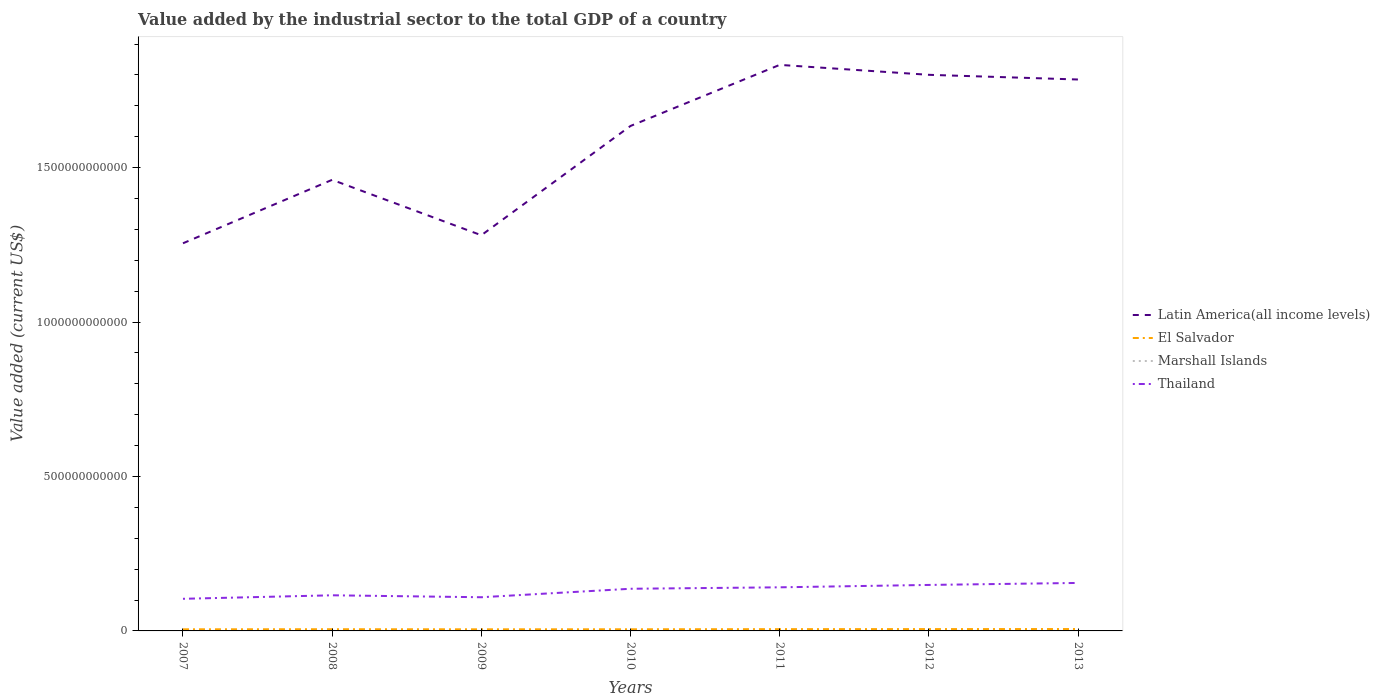Is the number of lines equal to the number of legend labels?
Provide a short and direct response. Yes. Across all years, what is the maximum value added by the industrial sector to the total GDP in Marshall Islands?
Keep it short and to the point. 1.76e+07. What is the total value added by the industrial sector to the total GDP in Thailand in the graph?
Offer a terse response. -3.25e+1. What is the difference between the highest and the second highest value added by the industrial sector to the total GDP in El Salvador?
Your answer should be compact. 8.95e+08. What is the difference between the highest and the lowest value added by the industrial sector to the total GDP in Thailand?
Your response must be concise. 4. How many lines are there?
Make the answer very short. 4. What is the difference between two consecutive major ticks on the Y-axis?
Keep it short and to the point. 5.00e+11. Does the graph contain any zero values?
Make the answer very short. No. Does the graph contain grids?
Your answer should be very brief. No. Where does the legend appear in the graph?
Offer a terse response. Center right. How are the legend labels stacked?
Keep it short and to the point. Vertical. What is the title of the graph?
Ensure brevity in your answer.  Value added by the industrial sector to the total GDP of a country. What is the label or title of the Y-axis?
Give a very brief answer. Value added (current US$). What is the Value added (current US$) in Latin America(all income levels) in 2007?
Provide a short and direct response. 1.26e+12. What is the Value added (current US$) in El Salvador in 2007?
Give a very brief answer. 5.23e+09. What is the Value added (current US$) of Marshall Islands in 2007?
Ensure brevity in your answer.  1.90e+07. What is the Value added (current US$) of Thailand in 2007?
Provide a short and direct response. 1.04e+11. What is the Value added (current US$) in Latin America(all income levels) in 2008?
Give a very brief answer. 1.46e+12. What is the Value added (current US$) of El Salvador in 2008?
Give a very brief answer. 5.49e+09. What is the Value added (current US$) of Marshall Islands in 2008?
Your response must be concise. 1.95e+07. What is the Value added (current US$) of Thailand in 2008?
Ensure brevity in your answer.  1.15e+11. What is the Value added (current US$) in Latin America(all income levels) in 2009?
Give a very brief answer. 1.28e+12. What is the Value added (current US$) in El Salvador in 2009?
Give a very brief answer. 5.21e+09. What is the Value added (current US$) in Marshall Islands in 2009?
Keep it short and to the point. 1.76e+07. What is the Value added (current US$) in Thailand in 2009?
Your answer should be compact. 1.09e+11. What is the Value added (current US$) in Latin America(all income levels) in 2010?
Provide a succinct answer. 1.63e+12. What is the Value added (current US$) in El Salvador in 2010?
Your response must be concise. 5.31e+09. What is the Value added (current US$) in Marshall Islands in 2010?
Offer a very short reply. 1.83e+07. What is the Value added (current US$) in Thailand in 2010?
Ensure brevity in your answer.  1.36e+11. What is the Value added (current US$) of Latin America(all income levels) in 2011?
Offer a very short reply. 1.83e+12. What is the Value added (current US$) of El Salvador in 2011?
Keep it short and to the point. 5.74e+09. What is the Value added (current US$) in Marshall Islands in 2011?
Provide a short and direct response. 2.13e+07. What is the Value added (current US$) in Thailand in 2011?
Your response must be concise. 1.41e+11. What is the Value added (current US$) in Latin America(all income levels) in 2012?
Make the answer very short. 1.80e+12. What is the Value added (current US$) in El Salvador in 2012?
Provide a succinct answer. 5.91e+09. What is the Value added (current US$) of Marshall Islands in 2012?
Make the answer very short. 1.97e+07. What is the Value added (current US$) of Thailand in 2012?
Your response must be concise. 1.49e+11. What is the Value added (current US$) of Latin America(all income levels) in 2013?
Give a very brief answer. 1.79e+12. What is the Value added (current US$) in El Salvador in 2013?
Provide a short and direct response. 6.10e+09. What is the Value added (current US$) of Marshall Islands in 2013?
Give a very brief answer. 1.86e+07. What is the Value added (current US$) of Thailand in 2013?
Your response must be concise. 1.55e+11. Across all years, what is the maximum Value added (current US$) of Latin America(all income levels)?
Ensure brevity in your answer.  1.83e+12. Across all years, what is the maximum Value added (current US$) of El Salvador?
Provide a succinct answer. 6.10e+09. Across all years, what is the maximum Value added (current US$) in Marshall Islands?
Make the answer very short. 2.13e+07. Across all years, what is the maximum Value added (current US$) in Thailand?
Keep it short and to the point. 1.55e+11. Across all years, what is the minimum Value added (current US$) of Latin America(all income levels)?
Your answer should be compact. 1.26e+12. Across all years, what is the minimum Value added (current US$) of El Salvador?
Ensure brevity in your answer.  5.21e+09. Across all years, what is the minimum Value added (current US$) in Marshall Islands?
Make the answer very short. 1.76e+07. Across all years, what is the minimum Value added (current US$) in Thailand?
Your answer should be very brief. 1.04e+11. What is the total Value added (current US$) of Latin America(all income levels) in the graph?
Ensure brevity in your answer.  1.10e+13. What is the total Value added (current US$) in El Salvador in the graph?
Provide a succinct answer. 3.90e+1. What is the total Value added (current US$) in Marshall Islands in the graph?
Provide a succinct answer. 1.34e+08. What is the total Value added (current US$) in Thailand in the graph?
Offer a terse response. 9.10e+11. What is the difference between the Value added (current US$) in Latin America(all income levels) in 2007 and that in 2008?
Make the answer very short. -2.05e+11. What is the difference between the Value added (current US$) in El Salvador in 2007 and that in 2008?
Ensure brevity in your answer.  -2.62e+08. What is the difference between the Value added (current US$) in Marshall Islands in 2007 and that in 2008?
Provide a short and direct response. -4.33e+05. What is the difference between the Value added (current US$) in Thailand in 2007 and that in 2008?
Ensure brevity in your answer.  -1.14e+1. What is the difference between the Value added (current US$) of Latin America(all income levels) in 2007 and that in 2009?
Your answer should be very brief. -2.60e+1. What is the difference between the Value added (current US$) of El Salvador in 2007 and that in 2009?
Your response must be concise. 2.62e+07. What is the difference between the Value added (current US$) in Marshall Islands in 2007 and that in 2009?
Your response must be concise. 1.47e+06. What is the difference between the Value added (current US$) of Thailand in 2007 and that in 2009?
Your answer should be very brief. -5.06e+09. What is the difference between the Value added (current US$) in Latin America(all income levels) in 2007 and that in 2010?
Your answer should be very brief. -3.80e+11. What is the difference between the Value added (current US$) in El Salvador in 2007 and that in 2010?
Offer a very short reply. -7.81e+07. What is the difference between the Value added (current US$) of Marshall Islands in 2007 and that in 2010?
Your answer should be compact. 7.64e+05. What is the difference between the Value added (current US$) of Thailand in 2007 and that in 2010?
Your answer should be compact. -3.25e+1. What is the difference between the Value added (current US$) in Latin America(all income levels) in 2007 and that in 2011?
Keep it short and to the point. -5.78e+11. What is the difference between the Value added (current US$) in El Salvador in 2007 and that in 2011?
Provide a succinct answer. -5.03e+08. What is the difference between the Value added (current US$) of Marshall Islands in 2007 and that in 2011?
Provide a succinct answer. -2.33e+06. What is the difference between the Value added (current US$) in Thailand in 2007 and that in 2011?
Your answer should be very brief. -3.72e+1. What is the difference between the Value added (current US$) in Latin America(all income levels) in 2007 and that in 2012?
Your response must be concise. -5.45e+11. What is the difference between the Value added (current US$) in El Salvador in 2007 and that in 2012?
Offer a terse response. -6.78e+08. What is the difference between the Value added (current US$) in Marshall Islands in 2007 and that in 2012?
Make the answer very short. -6.45e+05. What is the difference between the Value added (current US$) of Thailand in 2007 and that in 2012?
Your response must be concise. -4.49e+1. What is the difference between the Value added (current US$) of Latin America(all income levels) in 2007 and that in 2013?
Offer a very short reply. -5.30e+11. What is the difference between the Value added (current US$) of El Salvador in 2007 and that in 2013?
Provide a succinct answer. -8.69e+08. What is the difference between the Value added (current US$) of Marshall Islands in 2007 and that in 2013?
Keep it short and to the point. 3.76e+05. What is the difference between the Value added (current US$) in Thailand in 2007 and that in 2013?
Make the answer very short. -5.14e+1. What is the difference between the Value added (current US$) in Latin America(all income levels) in 2008 and that in 2009?
Your answer should be very brief. 1.79e+11. What is the difference between the Value added (current US$) of El Salvador in 2008 and that in 2009?
Your answer should be compact. 2.88e+08. What is the difference between the Value added (current US$) of Marshall Islands in 2008 and that in 2009?
Provide a succinct answer. 1.90e+06. What is the difference between the Value added (current US$) in Thailand in 2008 and that in 2009?
Your answer should be very brief. 6.30e+09. What is the difference between the Value added (current US$) in Latin America(all income levels) in 2008 and that in 2010?
Make the answer very short. -1.74e+11. What is the difference between the Value added (current US$) in El Salvador in 2008 and that in 2010?
Offer a terse response. 1.84e+08. What is the difference between the Value added (current US$) of Marshall Islands in 2008 and that in 2010?
Your answer should be very brief. 1.20e+06. What is the difference between the Value added (current US$) in Thailand in 2008 and that in 2010?
Make the answer very short. -2.11e+1. What is the difference between the Value added (current US$) of Latin America(all income levels) in 2008 and that in 2011?
Provide a short and direct response. -3.72e+11. What is the difference between the Value added (current US$) in El Salvador in 2008 and that in 2011?
Keep it short and to the point. -2.41e+08. What is the difference between the Value added (current US$) of Marshall Islands in 2008 and that in 2011?
Make the answer very short. -1.89e+06. What is the difference between the Value added (current US$) of Thailand in 2008 and that in 2011?
Provide a succinct answer. -2.58e+1. What is the difference between the Value added (current US$) of Latin America(all income levels) in 2008 and that in 2012?
Your answer should be compact. -3.40e+11. What is the difference between the Value added (current US$) of El Salvador in 2008 and that in 2012?
Your response must be concise. -4.16e+08. What is the difference between the Value added (current US$) in Marshall Islands in 2008 and that in 2012?
Your response must be concise. -2.12e+05. What is the difference between the Value added (current US$) of Thailand in 2008 and that in 2012?
Your response must be concise. -3.35e+1. What is the difference between the Value added (current US$) in Latin America(all income levels) in 2008 and that in 2013?
Your response must be concise. -3.25e+11. What is the difference between the Value added (current US$) of El Salvador in 2008 and that in 2013?
Keep it short and to the point. -6.07e+08. What is the difference between the Value added (current US$) of Marshall Islands in 2008 and that in 2013?
Offer a terse response. 8.09e+05. What is the difference between the Value added (current US$) of Thailand in 2008 and that in 2013?
Give a very brief answer. -4.00e+1. What is the difference between the Value added (current US$) in Latin America(all income levels) in 2009 and that in 2010?
Your answer should be very brief. -3.54e+11. What is the difference between the Value added (current US$) in El Salvador in 2009 and that in 2010?
Your response must be concise. -1.04e+08. What is the difference between the Value added (current US$) of Marshall Islands in 2009 and that in 2010?
Your answer should be compact. -7.02e+05. What is the difference between the Value added (current US$) in Thailand in 2009 and that in 2010?
Ensure brevity in your answer.  -2.74e+1. What is the difference between the Value added (current US$) in Latin America(all income levels) in 2009 and that in 2011?
Make the answer very short. -5.52e+11. What is the difference between the Value added (current US$) in El Salvador in 2009 and that in 2011?
Provide a short and direct response. -5.29e+08. What is the difference between the Value added (current US$) of Marshall Islands in 2009 and that in 2011?
Offer a terse response. -3.79e+06. What is the difference between the Value added (current US$) in Thailand in 2009 and that in 2011?
Offer a very short reply. -3.21e+1. What is the difference between the Value added (current US$) in Latin America(all income levels) in 2009 and that in 2012?
Make the answer very short. -5.19e+11. What is the difference between the Value added (current US$) in El Salvador in 2009 and that in 2012?
Offer a very short reply. -7.04e+08. What is the difference between the Value added (current US$) in Marshall Islands in 2009 and that in 2012?
Give a very brief answer. -2.11e+06. What is the difference between the Value added (current US$) of Thailand in 2009 and that in 2012?
Make the answer very short. -3.99e+1. What is the difference between the Value added (current US$) of Latin America(all income levels) in 2009 and that in 2013?
Provide a short and direct response. -5.04e+11. What is the difference between the Value added (current US$) of El Salvador in 2009 and that in 2013?
Offer a very short reply. -8.95e+08. What is the difference between the Value added (current US$) of Marshall Islands in 2009 and that in 2013?
Provide a succinct answer. -1.09e+06. What is the difference between the Value added (current US$) of Thailand in 2009 and that in 2013?
Ensure brevity in your answer.  -4.63e+1. What is the difference between the Value added (current US$) in Latin America(all income levels) in 2010 and that in 2011?
Your response must be concise. -1.98e+11. What is the difference between the Value added (current US$) in El Salvador in 2010 and that in 2011?
Keep it short and to the point. -4.25e+08. What is the difference between the Value added (current US$) of Marshall Islands in 2010 and that in 2011?
Your answer should be very brief. -3.09e+06. What is the difference between the Value added (current US$) of Thailand in 2010 and that in 2011?
Give a very brief answer. -4.69e+09. What is the difference between the Value added (current US$) of Latin America(all income levels) in 2010 and that in 2012?
Provide a short and direct response. -1.66e+11. What is the difference between the Value added (current US$) in El Salvador in 2010 and that in 2012?
Give a very brief answer. -6.00e+08. What is the difference between the Value added (current US$) of Marshall Islands in 2010 and that in 2012?
Your response must be concise. -1.41e+06. What is the difference between the Value added (current US$) in Thailand in 2010 and that in 2012?
Your answer should be compact. -1.24e+1. What is the difference between the Value added (current US$) in Latin America(all income levels) in 2010 and that in 2013?
Offer a very short reply. -1.50e+11. What is the difference between the Value added (current US$) of El Salvador in 2010 and that in 2013?
Keep it short and to the point. -7.91e+08. What is the difference between the Value added (current US$) of Marshall Islands in 2010 and that in 2013?
Ensure brevity in your answer.  -3.88e+05. What is the difference between the Value added (current US$) in Thailand in 2010 and that in 2013?
Make the answer very short. -1.89e+1. What is the difference between the Value added (current US$) in Latin America(all income levels) in 2011 and that in 2012?
Your answer should be very brief. 3.22e+1. What is the difference between the Value added (current US$) in El Salvador in 2011 and that in 2012?
Offer a terse response. -1.75e+08. What is the difference between the Value added (current US$) in Marshall Islands in 2011 and that in 2012?
Offer a terse response. 1.68e+06. What is the difference between the Value added (current US$) in Thailand in 2011 and that in 2012?
Your answer should be compact. -7.72e+09. What is the difference between the Value added (current US$) of Latin America(all income levels) in 2011 and that in 2013?
Keep it short and to the point. 4.73e+1. What is the difference between the Value added (current US$) in El Salvador in 2011 and that in 2013?
Give a very brief answer. -3.66e+08. What is the difference between the Value added (current US$) of Marshall Islands in 2011 and that in 2013?
Provide a succinct answer. 2.70e+06. What is the difference between the Value added (current US$) in Thailand in 2011 and that in 2013?
Give a very brief answer. -1.42e+1. What is the difference between the Value added (current US$) of Latin America(all income levels) in 2012 and that in 2013?
Offer a terse response. 1.52e+1. What is the difference between the Value added (current US$) of El Salvador in 2012 and that in 2013?
Provide a short and direct response. -1.91e+08. What is the difference between the Value added (current US$) of Marshall Islands in 2012 and that in 2013?
Your answer should be very brief. 1.02e+06. What is the difference between the Value added (current US$) in Thailand in 2012 and that in 2013?
Ensure brevity in your answer.  -6.46e+09. What is the difference between the Value added (current US$) in Latin America(all income levels) in 2007 and the Value added (current US$) in El Salvador in 2008?
Your answer should be very brief. 1.25e+12. What is the difference between the Value added (current US$) in Latin America(all income levels) in 2007 and the Value added (current US$) in Marshall Islands in 2008?
Offer a terse response. 1.25e+12. What is the difference between the Value added (current US$) of Latin America(all income levels) in 2007 and the Value added (current US$) of Thailand in 2008?
Your answer should be compact. 1.14e+12. What is the difference between the Value added (current US$) of El Salvador in 2007 and the Value added (current US$) of Marshall Islands in 2008?
Offer a very short reply. 5.21e+09. What is the difference between the Value added (current US$) in El Salvador in 2007 and the Value added (current US$) in Thailand in 2008?
Your answer should be compact. -1.10e+11. What is the difference between the Value added (current US$) of Marshall Islands in 2007 and the Value added (current US$) of Thailand in 2008?
Ensure brevity in your answer.  -1.15e+11. What is the difference between the Value added (current US$) of Latin America(all income levels) in 2007 and the Value added (current US$) of El Salvador in 2009?
Make the answer very short. 1.25e+12. What is the difference between the Value added (current US$) in Latin America(all income levels) in 2007 and the Value added (current US$) in Marshall Islands in 2009?
Offer a terse response. 1.25e+12. What is the difference between the Value added (current US$) of Latin America(all income levels) in 2007 and the Value added (current US$) of Thailand in 2009?
Offer a very short reply. 1.15e+12. What is the difference between the Value added (current US$) of El Salvador in 2007 and the Value added (current US$) of Marshall Islands in 2009?
Your response must be concise. 5.21e+09. What is the difference between the Value added (current US$) of El Salvador in 2007 and the Value added (current US$) of Thailand in 2009?
Provide a short and direct response. -1.04e+11. What is the difference between the Value added (current US$) of Marshall Islands in 2007 and the Value added (current US$) of Thailand in 2009?
Your answer should be very brief. -1.09e+11. What is the difference between the Value added (current US$) in Latin America(all income levels) in 2007 and the Value added (current US$) in El Salvador in 2010?
Give a very brief answer. 1.25e+12. What is the difference between the Value added (current US$) in Latin America(all income levels) in 2007 and the Value added (current US$) in Marshall Islands in 2010?
Offer a very short reply. 1.25e+12. What is the difference between the Value added (current US$) in Latin America(all income levels) in 2007 and the Value added (current US$) in Thailand in 2010?
Ensure brevity in your answer.  1.12e+12. What is the difference between the Value added (current US$) in El Salvador in 2007 and the Value added (current US$) in Marshall Islands in 2010?
Your answer should be compact. 5.21e+09. What is the difference between the Value added (current US$) of El Salvador in 2007 and the Value added (current US$) of Thailand in 2010?
Make the answer very short. -1.31e+11. What is the difference between the Value added (current US$) of Marshall Islands in 2007 and the Value added (current US$) of Thailand in 2010?
Your answer should be very brief. -1.36e+11. What is the difference between the Value added (current US$) in Latin America(all income levels) in 2007 and the Value added (current US$) in El Salvador in 2011?
Give a very brief answer. 1.25e+12. What is the difference between the Value added (current US$) of Latin America(all income levels) in 2007 and the Value added (current US$) of Marshall Islands in 2011?
Offer a very short reply. 1.25e+12. What is the difference between the Value added (current US$) of Latin America(all income levels) in 2007 and the Value added (current US$) of Thailand in 2011?
Your response must be concise. 1.11e+12. What is the difference between the Value added (current US$) in El Salvador in 2007 and the Value added (current US$) in Marshall Islands in 2011?
Give a very brief answer. 5.21e+09. What is the difference between the Value added (current US$) in El Salvador in 2007 and the Value added (current US$) in Thailand in 2011?
Offer a terse response. -1.36e+11. What is the difference between the Value added (current US$) of Marshall Islands in 2007 and the Value added (current US$) of Thailand in 2011?
Provide a succinct answer. -1.41e+11. What is the difference between the Value added (current US$) in Latin America(all income levels) in 2007 and the Value added (current US$) in El Salvador in 2012?
Provide a short and direct response. 1.25e+12. What is the difference between the Value added (current US$) in Latin America(all income levels) in 2007 and the Value added (current US$) in Marshall Islands in 2012?
Offer a terse response. 1.25e+12. What is the difference between the Value added (current US$) in Latin America(all income levels) in 2007 and the Value added (current US$) in Thailand in 2012?
Make the answer very short. 1.11e+12. What is the difference between the Value added (current US$) in El Salvador in 2007 and the Value added (current US$) in Marshall Islands in 2012?
Give a very brief answer. 5.21e+09. What is the difference between the Value added (current US$) of El Salvador in 2007 and the Value added (current US$) of Thailand in 2012?
Keep it short and to the point. -1.44e+11. What is the difference between the Value added (current US$) of Marshall Islands in 2007 and the Value added (current US$) of Thailand in 2012?
Ensure brevity in your answer.  -1.49e+11. What is the difference between the Value added (current US$) in Latin America(all income levels) in 2007 and the Value added (current US$) in El Salvador in 2013?
Offer a terse response. 1.25e+12. What is the difference between the Value added (current US$) in Latin America(all income levels) in 2007 and the Value added (current US$) in Marshall Islands in 2013?
Ensure brevity in your answer.  1.25e+12. What is the difference between the Value added (current US$) in Latin America(all income levels) in 2007 and the Value added (current US$) in Thailand in 2013?
Your response must be concise. 1.10e+12. What is the difference between the Value added (current US$) in El Salvador in 2007 and the Value added (current US$) in Marshall Islands in 2013?
Keep it short and to the point. 5.21e+09. What is the difference between the Value added (current US$) of El Salvador in 2007 and the Value added (current US$) of Thailand in 2013?
Keep it short and to the point. -1.50e+11. What is the difference between the Value added (current US$) in Marshall Islands in 2007 and the Value added (current US$) in Thailand in 2013?
Offer a terse response. -1.55e+11. What is the difference between the Value added (current US$) of Latin America(all income levels) in 2008 and the Value added (current US$) of El Salvador in 2009?
Offer a very short reply. 1.46e+12. What is the difference between the Value added (current US$) of Latin America(all income levels) in 2008 and the Value added (current US$) of Marshall Islands in 2009?
Offer a terse response. 1.46e+12. What is the difference between the Value added (current US$) of Latin America(all income levels) in 2008 and the Value added (current US$) of Thailand in 2009?
Give a very brief answer. 1.35e+12. What is the difference between the Value added (current US$) of El Salvador in 2008 and the Value added (current US$) of Marshall Islands in 2009?
Give a very brief answer. 5.48e+09. What is the difference between the Value added (current US$) of El Salvador in 2008 and the Value added (current US$) of Thailand in 2009?
Provide a succinct answer. -1.04e+11. What is the difference between the Value added (current US$) in Marshall Islands in 2008 and the Value added (current US$) in Thailand in 2009?
Your answer should be compact. -1.09e+11. What is the difference between the Value added (current US$) in Latin America(all income levels) in 2008 and the Value added (current US$) in El Salvador in 2010?
Make the answer very short. 1.46e+12. What is the difference between the Value added (current US$) in Latin America(all income levels) in 2008 and the Value added (current US$) in Marshall Islands in 2010?
Ensure brevity in your answer.  1.46e+12. What is the difference between the Value added (current US$) of Latin America(all income levels) in 2008 and the Value added (current US$) of Thailand in 2010?
Provide a short and direct response. 1.32e+12. What is the difference between the Value added (current US$) of El Salvador in 2008 and the Value added (current US$) of Marshall Islands in 2010?
Your answer should be very brief. 5.48e+09. What is the difference between the Value added (current US$) in El Salvador in 2008 and the Value added (current US$) in Thailand in 2010?
Keep it short and to the point. -1.31e+11. What is the difference between the Value added (current US$) in Marshall Islands in 2008 and the Value added (current US$) in Thailand in 2010?
Your answer should be very brief. -1.36e+11. What is the difference between the Value added (current US$) of Latin America(all income levels) in 2008 and the Value added (current US$) of El Salvador in 2011?
Give a very brief answer. 1.45e+12. What is the difference between the Value added (current US$) of Latin America(all income levels) in 2008 and the Value added (current US$) of Marshall Islands in 2011?
Make the answer very short. 1.46e+12. What is the difference between the Value added (current US$) in Latin America(all income levels) in 2008 and the Value added (current US$) in Thailand in 2011?
Your response must be concise. 1.32e+12. What is the difference between the Value added (current US$) in El Salvador in 2008 and the Value added (current US$) in Marshall Islands in 2011?
Ensure brevity in your answer.  5.47e+09. What is the difference between the Value added (current US$) of El Salvador in 2008 and the Value added (current US$) of Thailand in 2011?
Make the answer very short. -1.36e+11. What is the difference between the Value added (current US$) in Marshall Islands in 2008 and the Value added (current US$) in Thailand in 2011?
Offer a very short reply. -1.41e+11. What is the difference between the Value added (current US$) of Latin America(all income levels) in 2008 and the Value added (current US$) of El Salvador in 2012?
Your answer should be very brief. 1.45e+12. What is the difference between the Value added (current US$) of Latin America(all income levels) in 2008 and the Value added (current US$) of Marshall Islands in 2012?
Your answer should be compact. 1.46e+12. What is the difference between the Value added (current US$) of Latin America(all income levels) in 2008 and the Value added (current US$) of Thailand in 2012?
Offer a terse response. 1.31e+12. What is the difference between the Value added (current US$) in El Salvador in 2008 and the Value added (current US$) in Marshall Islands in 2012?
Provide a succinct answer. 5.47e+09. What is the difference between the Value added (current US$) of El Salvador in 2008 and the Value added (current US$) of Thailand in 2012?
Your response must be concise. -1.43e+11. What is the difference between the Value added (current US$) of Marshall Islands in 2008 and the Value added (current US$) of Thailand in 2012?
Ensure brevity in your answer.  -1.49e+11. What is the difference between the Value added (current US$) of Latin America(all income levels) in 2008 and the Value added (current US$) of El Salvador in 2013?
Make the answer very short. 1.45e+12. What is the difference between the Value added (current US$) in Latin America(all income levels) in 2008 and the Value added (current US$) in Marshall Islands in 2013?
Your answer should be compact. 1.46e+12. What is the difference between the Value added (current US$) of Latin America(all income levels) in 2008 and the Value added (current US$) of Thailand in 2013?
Your answer should be very brief. 1.31e+12. What is the difference between the Value added (current US$) in El Salvador in 2008 and the Value added (current US$) in Marshall Islands in 2013?
Your answer should be very brief. 5.48e+09. What is the difference between the Value added (current US$) of El Salvador in 2008 and the Value added (current US$) of Thailand in 2013?
Your response must be concise. -1.50e+11. What is the difference between the Value added (current US$) in Marshall Islands in 2008 and the Value added (current US$) in Thailand in 2013?
Ensure brevity in your answer.  -1.55e+11. What is the difference between the Value added (current US$) of Latin America(all income levels) in 2009 and the Value added (current US$) of El Salvador in 2010?
Keep it short and to the point. 1.28e+12. What is the difference between the Value added (current US$) of Latin America(all income levels) in 2009 and the Value added (current US$) of Marshall Islands in 2010?
Provide a succinct answer. 1.28e+12. What is the difference between the Value added (current US$) in Latin America(all income levels) in 2009 and the Value added (current US$) in Thailand in 2010?
Keep it short and to the point. 1.14e+12. What is the difference between the Value added (current US$) of El Salvador in 2009 and the Value added (current US$) of Marshall Islands in 2010?
Keep it short and to the point. 5.19e+09. What is the difference between the Value added (current US$) in El Salvador in 2009 and the Value added (current US$) in Thailand in 2010?
Keep it short and to the point. -1.31e+11. What is the difference between the Value added (current US$) in Marshall Islands in 2009 and the Value added (current US$) in Thailand in 2010?
Keep it short and to the point. -1.36e+11. What is the difference between the Value added (current US$) in Latin America(all income levels) in 2009 and the Value added (current US$) in El Salvador in 2011?
Your answer should be very brief. 1.28e+12. What is the difference between the Value added (current US$) in Latin America(all income levels) in 2009 and the Value added (current US$) in Marshall Islands in 2011?
Offer a terse response. 1.28e+12. What is the difference between the Value added (current US$) of Latin America(all income levels) in 2009 and the Value added (current US$) of Thailand in 2011?
Make the answer very short. 1.14e+12. What is the difference between the Value added (current US$) of El Salvador in 2009 and the Value added (current US$) of Marshall Islands in 2011?
Provide a succinct answer. 5.18e+09. What is the difference between the Value added (current US$) of El Salvador in 2009 and the Value added (current US$) of Thailand in 2011?
Offer a terse response. -1.36e+11. What is the difference between the Value added (current US$) of Marshall Islands in 2009 and the Value added (current US$) of Thailand in 2011?
Your response must be concise. -1.41e+11. What is the difference between the Value added (current US$) of Latin America(all income levels) in 2009 and the Value added (current US$) of El Salvador in 2012?
Provide a succinct answer. 1.28e+12. What is the difference between the Value added (current US$) in Latin America(all income levels) in 2009 and the Value added (current US$) in Marshall Islands in 2012?
Provide a succinct answer. 1.28e+12. What is the difference between the Value added (current US$) in Latin America(all income levels) in 2009 and the Value added (current US$) in Thailand in 2012?
Offer a terse response. 1.13e+12. What is the difference between the Value added (current US$) in El Salvador in 2009 and the Value added (current US$) in Marshall Islands in 2012?
Provide a succinct answer. 5.19e+09. What is the difference between the Value added (current US$) in El Salvador in 2009 and the Value added (current US$) in Thailand in 2012?
Your answer should be compact. -1.44e+11. What is the difference between the Value added (current US$) of Marshall Islands in 2009 and the Value added (current US$) of Thailand in 2012?
Offer a terse response. -1.49e+11. What is the difference between the Value added (current US$) of Latin America(all income levels) in 2009 and the Value added (current US$) of El Salvador in 2013?
Ensure brevity in your answer.  1.27e+12. What is the difference between the Value added (current US$) in Latin America(all income levels) in 2009 and the Value added (current US$) in Marshall Islands in 2013?
Provide a short and direct response. 1.28e+12. What is the difference between the Value added (current US$) of Latin America(all income levels) in 2009 and the Value added (current US$) of Thailand in 2013?
Ensure brevity in your answer.  1.13e+12. What is the difference between the Value added (current US$) in El Salvador in 2009 and the Value added (current US$) in Marshall Islands in 2013?
Give a very brief answer. 5.19e+09. What is the difference between the Value added (current US$) of El Salvador in 2009 and the Value added (current US$) of Thailand in 2013?
Your answer should be compact. -1.50e+11. What is the difference between the Value added (current US$) of Marshall Islands in 2009 and the Value added (current US$) of Thailand in 2013?
Offer a terse response. -1.55e+11. What is the difference between the Value added (current US$) of Latin America(all income levels) in 2010 and the Value added (current US$) of El Salvador in 2011?
Offer a very short reply. 1.63e+12. What is the difference between the Value added (current US$) of Latin America(all income levels) in 2010 and the Value added (current US$) of Marshall Islands in 2011?
Keep it short and to the point. 1.63e+12. What is the difference between the Value added (current US$) in Latin America(all income levels) in 2010 and the Value added (current US$) in Thailand in 2011?
Keep it short and to the point. 1.49e+12. What is the difference between the Value added (current US$) of El Salvador in 2010 and the Value added (current US$) of Marshall Islands in 2011?
Your answer should be compact. 5.29e+09. What is the difference between the Value added (current US$) in El Salvador in 2010 and the Value added (current US$) in Thailand in 2011?
Offer a very short reply. -1.36e+11. What is the difference between the Value added (current US$) of Marshall Islands in 2010 and the Value added (current US$) of Thailand in 2011?
Your response must be concise. -1.41e+11. What is the difference between the Value added (current US$) of Latin America(all income levels) in 2010 and the Value added (current US$) of El Salvador in 2012?
Your response must be concise. 1.63e+12. What is the difference between the Value added (current US$) of Latin America(all income levels) in 2010 and the Value added (current US$) of Marshall Islands in 2012?
Offer a very short reply. 1.63e+12. What is the difference between the Value added (current US$) of Latin America(all income levels) in 2010 and the Value added (current US$) of Thailand in 2012?
Provide a succinct answer. 1.49e+12. What is the difference between the Value added (current US$) of El Salvador in 2010 and the Value added (current US$) of Marshall Islands in 2012?
Your response must be concise. 5.29e+09. What is the difference between the Value added (current US$) of El Salvador in 2010 and the Value added (current US$) of Thailand in 2012?
Make the answer very short. -1.44e+11. What is the difference between the Value added (current US$) of Marshall Islands in 2010 and the Value added (current US$) of Thailand in 2012?
Give a very brief answer. -1.49e+11. What is the difference between the Value added (current US$) of Latin America(all income levels) in 2010 and the Value added (current US$) of El Salvador in 2013?
Provide a succinct answer. 1.63e+12. What is the difference between the Value added (current US$) in Latin America(all income levels) in 2010 and the Value added (current US$) in Marshall Islands in 2013?
Keep it short and to the point. 1.63e+12. What is the difference between the Value added (current US$) of Latin America(all income levels) in 2010 and the Value added (current US$) of Thailand in 2013?
Ensure brevity in your answer.  1.48e+12. What is the difference between the Value added (current US$) of El Salvador in 2010 and the Value added (current US$) of Marshall Islands in 2013?
Provide a short and direct response. 5.29e+09. What is the difference between the Value added (current US$) in El Salvador in 2010 and the Value added (current US$) in Thailand in 2013?
Make the answer very short. -1.50e+11. What is the difference between the Value added (current US$) in Marshall Islands in 2010 and the Value added (current US$) in Thailand in 2013?
Offer a terse response. -1.55e+11. What is the difference between the Value added (current US$) of Latin America(all income levels) in 2011 and the Value added (current US$) of El Salvador in 2012?
Your answer should be very brief. 1.83e+12. What is the difference between the Value added (current US$) of Latin America(all income levels) in 2011 and the Value added (current US$) of Marshall Islands in 2012?
Offer a very short reply. 1.83e+12. What is the difference between the Value added (current US$) of Latin America(all income levels) in 2011 and the Value added (current US$) of Thailand in 2012?
Your answer should be very brief. 1.68e+12. What is the difference between the Value added (current US$) of El Salvador in 2011 and the Value added (current US$) of Marshall Islands in 2012?
Your answer should be very brief. 5.72e+09. What is the difference between the Value added (current US$) in El Salvador in 2011 and the Value added (current US$) in Thailand in 2012?
Offer a very short reply. -1.43e+11. What is the difference between the Value added (current US$) in Marshall Islands in 2011 and the Value added (current US$) in Thailand in 2012?
Give a very brief answer. -1.49e+11. What is the difference between the Value added (current US$) of Latin America(all income levels) in 2011 and the Value added (current US$) of El Salvador in 2013?
Ensure brevity in your answer.  1.83e+12. What is the difference between the Value added (current US$) in Latin America(all income levels) in 2011 and the Value added (current US$) in Marshall Islands in 2013?
Make the answer very short. 1.83e+12. What is the difference between the Value added (current US$) in Latin America(all income levels) in 2011 and the Value added (current US$) in Thailand in 2013?
Keep it short and to the point. 1.68e+12. What is the difference between the Value added (current US$) of El Salvador in 2011 and the Value added (current US$) of Marshall Islands in 2013?
Offer a terse response. 5.72e+09. What is the difference between the Value added (current US$) in El Salvador in 2011 and the Value added (current US$) in Thailand in 2013?
Your answer should be compact. -1.50e+11. What is the difference between the Value added (current US$) in Marshall Islands in 2011 and the Value added (current US$) in Thailand in 2013?
Give a very brief answer. -1.55e+11. What is the difference between the Value added (current US$) in Latin America(all income levels) in 2012 and the Value added (current US$) in El Salvador in 2013?
Provide a succinct answer. 1.79e+12. What is the difference between the Value added (current US$) in Latin America(all income levels) in 2012 and the Value added (current US$) in Marshall Islands in 2013?
Your response must be concise. 1.80e+12. What is the difference between the Value added (current US$) in Latin America(all income levels) in 2012 and the Value added (current US$) in Thailand in 2013?
Provide a short and direct response. 1.65e+12. What is the difference between the Value added (current US$) in El Salvador in 2012 and the Value added (current US$) in Marshall Islands in 2013?
Give a very brief answer. 5.89e+09. What is the difference between the Value added (current US$) of El Salvador in 2012 and the Value added (current US$) of Thailand in 2013?
Offer a terse response. -1.49e+11. What is the difference between the Value added (current US$) of Marshall Islands in 2012 and the Value added (current US$) of Thailand in 2013?
Your answer should be compact. -1.55e+11. What is the average Value added (current US$) in Latin America(all income levels) per year?
Keep it short and to the point. 1.58e+12. What is the average Value added (current US$) in El Salvador per year?
Your answer should be very brief. 5.57e+09. What is the average Value added (current US$) in Marshall Islands per year?
Keep it short and to the point. 1.91e+07. What is the average Value added (current US$) in Thailand per year?
Keep it short and to the point. 1.30e+11. In the year 2007, what is the difference between the Value added (current US$) of Latin America(all income levels) and Value added (current US$) of El Salvador?
Provide a succinct answer. 1.25e+12. In the year 2007, what is the difference between the Value added (current US$) of Latin America(all income levels) and Value added (current US$) of Marshall Islands?
Ensure brevity in your answer.  1.25e+12. In the year 2007, what is the difference between the Value added (current US$) of Latin America(all income levels) and Value added (current US$) of Thailand?
Ensure brevity in your answer.  1.15e+12. In the year 2007, what is the difference between the Value added (current US$) in El Salvador and Value added (current US$) in Marshall Islands?
Ensure brevity in your answer.  5.21e+09. In the year 2007, what is the difference between the Value added (current US$) of El Salvador and Value added (current US$) of Thailand?
Your response must be concise. -9.88e+1. In the year 2007, what is the difference between the Value added (current US$) of Marshall Islands and Value added (current US$) of Thailand?
Your answer should be compact. -1.04e+11. In the year 2008, what is the difference between the Value added (current US$) in Latin America(all income levels) and Value added (current US$) in El Salvador?
Offer a very short reply. 1.45e+12. In the year 2008, what is the difference between the Value added (current US$) of Latin America(all income levels) and Value added (current US$) of Marshall Islands?
Provide a short and direct response. 1.46e+12. In the year 2008, what is the difference between the Value added (current US$) in Latin America(all income levels) and Value added (current US$) in Thailand?
Your answer should be compact. 1.35e+12. In the year 2008, what is the difference between the Value added (current US$) of El Salvador and Value added (current US$) of Marshall Islands?
Keep it short and to the point. 5.47e+09. In the year 2008, what is the difference between the Value added (current US$) in El Salvador and Value added (current US$) in Thailand?
Your answer should be compact. -1.10e+11. In the year 2008, what is the difference between the Value added (current US$) in Marshall Islands and Value added (current US$) in Thailand?
Offer a very short reply. -1.15e+11. In the year 2009, what is the difference between the Value added (current US$) of Latin America(all income levels) and Value added (current US$) of El Salvador?
Provide a succinct answer. 1.28e+12. In the year 2009, what is the difference between the Value added (current US$) of Latin America(all income levels) and Value added (current US$) of Marshall Islands?
Offer a very short reply. 1.28e+12. In the year 2009, what is the difference between the Value added (current US$) of Latin America(all income levels) and Value added (current US$) of Thailand?
Offer a very short reply. 1.17e+12. In the year 2009, what is the difference between the Value added (current US$) of El Salvador and Value added (current US$) of Marshall Islands?
Provide a short and direct response. 5.19e+09. In the year 2009, what is the difference between the Value added (current US$) in El Salvador and Value added (current US$) in Thailand?
Provide a succinct answer. -1.04e+11. In the year 2009, what is the difference between the Value added (current US$) in Marshall Islands and Value added (current US$) in Thailand?
Provide a short and direct response. -1.09e+11. In the year 2010, what is the difference between the Value added (current US$) of Latin America(all income levels) and Value added (current US$) of El Salvador?
Provide a succinct answer. 1.63e+12. In the year 2010, what is the difference between the Value added (current US$) of Latin America(all income levels) and Value added (current US$) of Marshall Islands?
Make the answer very short. 1.63e+12. In the year 2010, what is the difference between the Value added (current US$) of Latin America(all income levels) and Value added (current US$) of Thailand?
Give a very brief answer. 1.50e+12. In the year 2010, what is the difference between the Value added (current US$) of El Salvador and Value added (current US$) of Marshall Islands?
Your answer should be compact. 5.29e+09. In the year 2010, what is the difference between the Value added (current US$) of El Salvador and Value added (current US$) of Thailand?
Offer a terse response. -1.31e+11. In the year 2010, what is the difference between the Value added (current US$) in Marshall Islands and Value added (current US$) in Thailand?
Give a very brief answer. -1.36e+11. In the year 2011, what is the difference between the Value added (current US$) in Latin America(all income levels) and Value added (current US$) in El Salvador?
Make the answer very short. 1.83e+12. In the year 2011, what is the difference between the Value added (current US$) of Latin America(all income levels) and Value added (current US$) of Marshall Islands?
Keep it short and to the point. 1.83e+12. In the year 2011, what is the difference between the Value added (current US$) of Latin America(all income levels) and Value added (current US$) of Thailand?
Keep it short and to the point. 1.69e+12. In the year 2011, what is the difference between the Value added (current US$) of El Salvador and Value added (current US$) of Marshall Islands?
Provide a short and direct response. 5.71e+09. In the year 2011, what is the difference between the Value added (current US$) in El Salvador and Value added (current US$) in Thailand?
Ensure brevity in your answer.  -1.35e+11. In the year 2011, what is the difference between the Value added (current US$) in Marshall Islands and Value added (current US$) in Thailand?
Ensure brevity in your answer.  -1.41e+11. In the year 2012, what is the difference between the Value added (current US$) of Latin America(all income levels) and Value added (current US$) of El Salvador?
Offer a terse response. 1.79e+12. In the year 2012, what is the difference between the Value added (current US$) of Latin America(all income levels) and Value added (current US$) of Marshall Islands?
Your answer should be very brief. 1.80e+12. In the year 2012, what is the difference between the Value added (current US$) in Latin America(all income levels) and Value added (current US$) in Thailand?
Keep it short and to the point. 1.65e+12. In the year 2012, what is the difference between the Value added (current US$) of El Salvador and Value added (current US$) of Marshall Islands?
Give a very brief answer. 5.89e+09. In the year 2012, what is the difference between the Value added (current US$) of El Salvador and Value added (current US$) of Thailand?
Provide a short and direct response. -1.43e+11. In the year 2012, what is the difference between the Value added (current US$) of Marshall Islands and Value added (current US$) of Thailand?
Offer a very short reply. -1.49e+11. In the year 2013, what is the difference between the Value added (current US$) of Latin America(all income levels) and Value added (current US$) of El Salvador?
Ensure brevity in your answer.  1.78e+12. In the year 2013, what is the difference between the Value added (current US$) of Latin America(all income levels) and Value added (current US$) of Marshall Islands?
Ensure brevity in your answer.  1.79e+12. In the year 2013, what is the difference between the Value added (current US$) of Latin America(all income levels) and Value added (current US$) of Thailand?
Your answer should be compact. 1.63e+12. In the year 2013, what is the difference between the Value added (current US$) in El Salvador and Value added (current US$) in Marshall Islands?
Make the answer very short. 6.08e+09. In the year 2013, what is the difference between the Value added (current US$) in El Salvador and Value added (current US$) in Thailand?
Your answer should be compact. -1.49e+11. In the year 2013, what is the difference between the Value added (current US$) of Marshall Islands and Value added (current US$) of Thailand?
Offer a terse response. -1.55e+11. What is the ratio of the Value added (current US$) of Latin America(all income levels) in 2007 to that in 2008?
Provide a short and direct response. 0.86. What is the ratio of the Value added (current US$) of El Salvador in 2007 to that in 2008?
Keep it short and to the point. 0.95. What is the ratio of the Value added (current US$) of Marshall Islands in 2007 to that in 2008?
Provide a succinct answer. 0.98. What is the ratio of the Value added (current US$) of Thailand in 2007 to that in 2008?
Offer a very short reply. 0.9. What is the ratio of the Value added (current US$) in Latin America(all income levels) in 2007 to that in 2009?
Ensure brevity in your answer.  0.98. What is the ratio of the Value added (current US$) in El Salvador in 2007 to that in 2009?
Offer a terse response. 1. What is the ratio of the Value added (current US$) in Marshall Islands in 2007 to that in 2009?
Your answer should be very brief. 1.08. What is the ratio of the Value added (current US$) of Thailand in 2007 to that in 2009?
Ensure brevity in your answer.  0.95. What is the ratio of the Value added (current US$) of Latin America(all income levels) in 2007 to that in 2010?
Your answer should be compact. 0.77. What is the ratio of the Value added (current US$) of El Salvador in 2007 to that in 2010?
Keep it short and to the point. 0.99. What is the ratio of the Value added (current US$) of Marshall Islands in 2007 to that in 2010?
Provide a short and direct response. 1.04. What is the ratio of the Value added (current US$) of Thailand in 2007 to that in 2010?
Make the answer very short. 0.76. What is the ratio of the Value added (current US$) of Latin America(all income levels) in 2007 to that in 2011?
Offer a terse response. 0.68. What is the ratio of the Value added (current US$) in El Salvador in 2007 to that in 2011?
Make the answer very short. 0.91. What is the ratio of the Value added (current US$) in Marshall Islands in 2007 to that in 2011?
Provide a short and direct response. 0.89. What is the ratio of the Value added (current US$) of Thailand in 2007 to that in 2011?
Your answer should be very brief. 0.74. What is the ratio of the Value added (current US$) in Latin America(all income levels) in 2007 to that in 2012?
Your answer should be very brief. 0.7. What is the ratio of the Value added (current US$) of El Salvador in 2007 to that in 2012?
Offer a terse response. 0.89. What is the ratio of the Value added (current US$) of Marshall Islands in 2007 to that in 2012?
Offer a terse response. 0.97. What is the ratio of the Value added (current US$) in Thailand in 2007 to that in 2012?
Your answer should be very brief. 0.7. What is the ratio of the Value added (current US$) in Latin America(all income levels) in 2007 to that in 2013?
Ensure brevity in your answer.  0.7. What is the ratio of the Value added (current US$) of El Salvador in 2007 to that in 2013?
Provide a short and direct response. 0.86. What is the ratio of the Value added (current US$) in Marshall Islands in 2007 to that in 2013?
Provide a short and direct response. 1.02. What is the ratio of the Value added (current US$) of Thailand in 2007 to that in 2013?
Ensure brevity in your answer.  0.67. What is the ratio of the Value added (current US$) of Latin America(all income levels) in 2008 to that in 2009?
Ensure brevity in your answer.  1.14. What is the ratio of the Value added (current US$) of El Salvador in 2008 to that in 2009?
Offer a very short reply. 1.06. What is the ratio of the Value added (current US$) in Marshall Islands in 2008 to that in 2009?
Your response must be concise. 1.11. What is the ratio of the Value added (current US$) in Thailand in 2008 to that in 2009?
Keep it short and to the point. 1.06. What is the ratio of the Value added (current US$) in Latin America(all income levels) in 2008 to that in 2010?
Make the answer very short. 0.89. What is the ratio of the Value added (current US$) of El Salvador in 2008 to that in 2010?
Offer a terse response. 1.03. What is the ratio of the Value added (current US$) in Marshall Islands in 2008 to that in 2010?
Your answer should be compact. 1.07. What is the ratio of the Value added (current US$) in Thailand in 2008 to that in 2010?
Offer a terse response. 0.85. What is the ratio of the Value added (current US$) in Latin America(all income levels) in 2008 to that in 2011?
Ensure brevity in your answer.  0.8. What is the ratio of the Value added (current US$) in El Salvador in 2008 to that in 2011?
Your response must be concise. 0.96. What is the ratio of the Value added (current US$) of Marshall Islands in 2008 to that in 2011?
Make the answer very short. 0.91. What is the ratio of the Value added (current US$) of Thailand in 2008 to that in 2011?
Provide a succinct answer. 0.82. What is the ratio of the Value added (current US$) in Latin America(all income levels) in 2008 to that in 2012?
Your response must be concise. 0.81. What is the ratio of the Value added (current US$) of El Salvador in 2008 to that in 2012?
Your answer should be compact. 0.93. What is the ratio of the Value added (current US$) in Thailand in 2008 to that in 2012?
Keep it short and to the point. 0.77. What is the ratio of the Value added (current US$) of Latin America(all income levels) in 2008 to that in 2013?
Offer a terse response. 0.82. What is the ratio of the Value added (current US$) in El Salvador in 2008 to that in 2013?
Give a very brief answer. 0.9. What is the ratio of the Value added (current US$) of Marshall Islands in 2008 to that in 2013?
Your answer should be very brief. 1.04. What is the ratio of the Value added (current US$) in Thailand in 2008 to that in 2013?
Provide a succinct answer. 0.74. What is the ratio of the Value added (current US$) in Latin America(all income levels) in 2009 to that in 2010?
Offer a very short reply. 0.78. What is the ratio of the Value added (current US$) of El Salvador in 2009 to that in 2010?
Offer a very short reply. 0.98. What is the ratio of the Value added (current US$) in Marshall Islands in 2009 to that in 2010?
Ensure brevity in your answer.  0.96. What is the ratio of the Value added (current US$) of Thailand in 2009 to that in 2010?
Offer a terse response. 0.8. What is the ratio of the Value added (current US$) in Latin America(all income levels) in 2009 to that in 2011?
Your answer should be compact. 0.7. What is the ratio of the Value added (current US$) in El Salvador in 2009 to that in 2011?
Ensure brevity in your answer.  0.91. What is the ratio of the Value added (current US$) of Marshall Islands in 2009 to that in 2011?
Offer a terse response. 0.82. What is the ratio of the Value added (current US$) in Thailand in 2009 to that in 2011?
Provide a short and direct response. 0.77. What is the ratio of the Value added (current US$) in Latin America(all income levels) in 2009 to that in 2012?
Offer a very short reply. 0.71. What is the ratio of the Value added (current US$) in El Salvador in 2009 to that in 2012?
Your answer should be very brief. 0.88. What is the ratio of the Value added (current US$) of Marshall Islands in 2009 to that in 2012?
Your answer should be very brief. 0.89. What is the ratio of the Value added (current US$) in Thailand in 2009 to that in 2012?
Ensure brevity in your answer.  0.73. What is the ratio of the Value added (current US$) of Latin America(all income levels) in 2009 to that in 2013?
Your answer should be compact. 0.72. What is the ratio of the Value added (current US$) of El Salvador in 2009 to that in 2013?
Your response must be concise. 0.85. What is the ratio of the Value added (current US$) of Marshall Islands in 2009 to that in 2013?
Your response must be concise. 0.94. What is the ratio of the Value added (current US$) of Thailand in 2009 to that in 2013?
Offer a very short reply. 0.7. What is the ratio of the Value added (current US$) in Latin America(all income levels) in 2010 to that in 2011?
Give a very brief answer. 0.89. What is the ratio of the Value added (current US$) in El Salvador in 2010 to that in 2011?
Give a very brief answer. 0.93. What is the ratio of the Value added (current US$) in Marshall Islands in 2010 to that in 2011?
Ensure brevity in your answer.  0.86. What is the ratio of the Value added (current US$) of Thailand in 2010 to that in 2011?
Your answer should be very brief. 0.97. What is the ratio of the Value added (current US$) of Latin America(all income levels) in 2010 to that in 2012?
Your answer should be compact. 0.91. What is the ratio of the Value added (current US$) in El Salvador in 2010 to that in 2012?
Offer a very short reply. 0.9. What is the ratio of the Value added (current US$) in Marshall Islands in 2010 to that in 2012?
Provide a short and direct response. 0.93. What is the ratio of the Value added (current US$) in Latin America(all income levels) in 2010 to that in 2013?
Make the answer very short. 0.92. What is the ratio of the Value added (current US$) in El Salvador in 2010 to that in 2013?
Give a very brief answer. 0.87. What is the ratio of the Value added (current US$) in Marshall Islands in 2010 to that in 2013?
Give a very brief answer. 0.98. What is the ratio of the Value added (current US$) in Thailand in 2010 to that in 2013?
Provide a succinct answer. 0.88. What is the ratio of the Value added (current US$) in Latin America(all income levels) in 2011 to that in 2012?
Make the answer very short. 1.02. What is the ratio of the Value added (current US$) in El Salvador in 2011 to that in 2012?
Offer a very short reply. 0.97. What is the ratio of the Value added (current US$) of Marshall Islands in 2011 to that in 2012?
Keep it short and to the point. 1.09. What is the ratio of the Value added (current US$) in Thailand in 2011 to that in 2012?
Make the answer very short. 0.95. What is the ratio of the Value added (current US$) of Latin America(all income levels) in 2011 to that in 2013?
Ensure brevity in your answer.  1.03. What is the ratio of the Value added (current US$) of Marshall Islands in 2011 to that in 2013?
Your answer should be very brief. 1.15. What is the ratio of the Value added (current US$) of Thailand in 2011 to that in 2013?
Your response must be concise. 0.91. What is the ratio of the Value added (current US$) in Latin America(all income levels) in 2012 to that in 2013?
Your answer should be compact. 1.01. What is the ratio of the Value added (current US$) in El Salvador in 2012 to that in 2013?
Your response must be concise. 0.97. What is the ratio of the Value added (current US$) of Marshall Islands in 2012 to that in 2013?
Give a very brief answer. 1.05. What is the ratio of the Value added (current US$) in Thailand in 2012 to that in 2013?
Keep it short and to the point. 0.96. What is the difference between the highest and the second highest Value added (current US$) in Latin America(all income levels)?
Offer a terse response. 3.22e+1. What is the difference between the highest and the second highest Value added (current US$) in El Salvador?
Keep it short and to the point. 1.91e+08. What is the difference between the highest and the second highest Value added (current US$) in Marshall Islands?
Provide a succinct answer. 1.68e+06. What is the difference between the highest and the second highest Value added (current US$) of Thailand?
Your response must be concise. 6.46e+09. What is the difference between the highest and the lowest Value added (current US$) of Latin America(all income levels)?
Give a very brief answer. 5.78e+11. What is the difference between the highest and the lowest Value added (current US$) in El Salvador?
Your response must be concise. 8.95e+08. What is the difference between the highest and the lowest Value added (current US$) of Marshall Islands?
Keep it short and to the point. 3.79e+06. What is the difference between the highest and the lowest Value added (current US$) of Thailand?
Your response must be concise. 5.14e+1. 